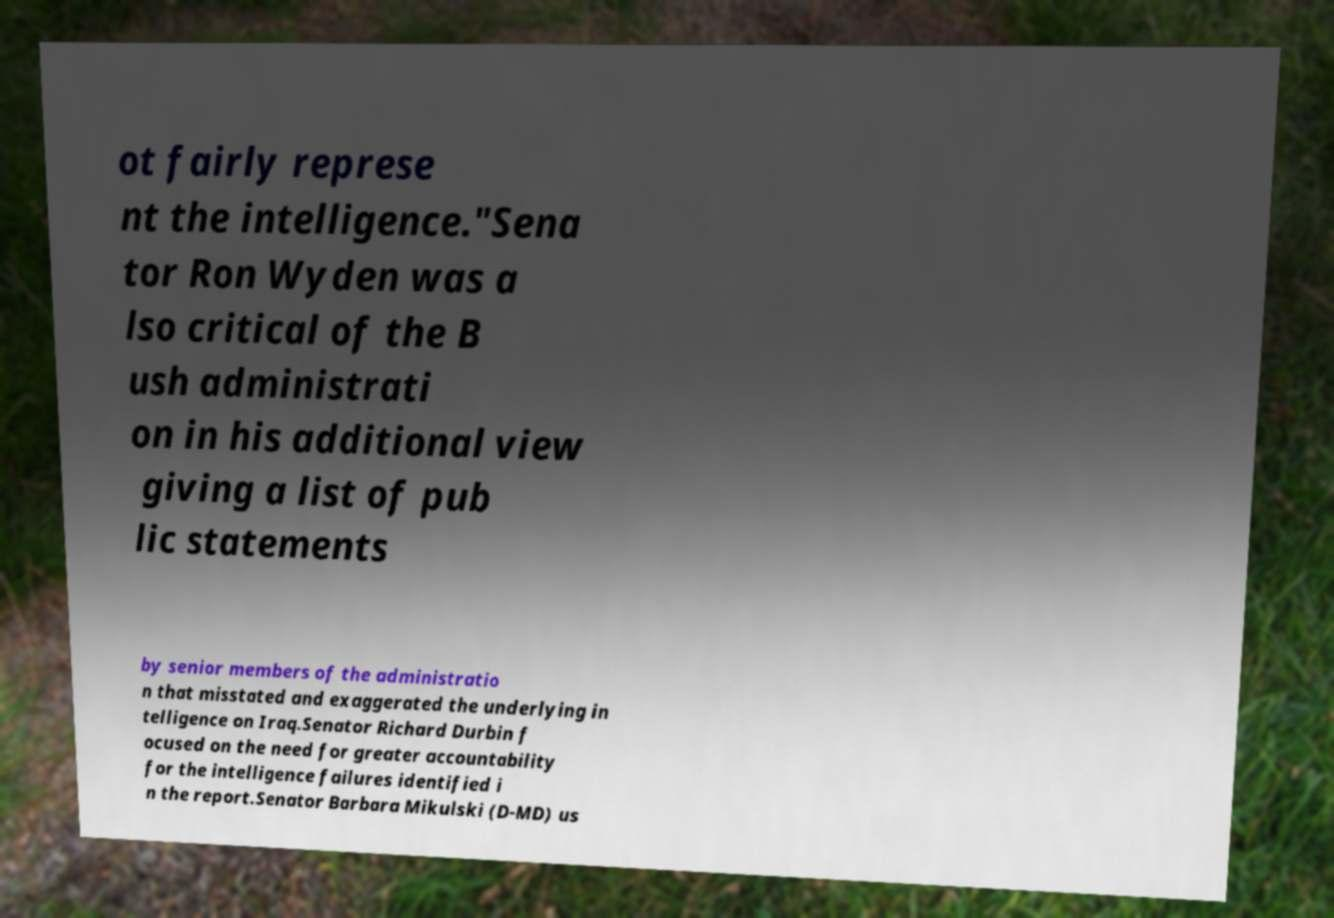Can you read and provide the text displayed in the image?This photo seems to have some interesting text. Can you extract and type it out for me? ot fairly represe nt the intelligence."Sena tor Ron Wyden was a lso critical of the B ush administrati on in his additional view giving a list of pub lic statements by senior members of the administratio n that misstated and exaggerated the underlying in telligence on Iraq.Senator Richard Durbin f ocused on the need for greater accountability for the intelligence failures identified i n the report.Senator Barbara Mikulski (D-MD) us 